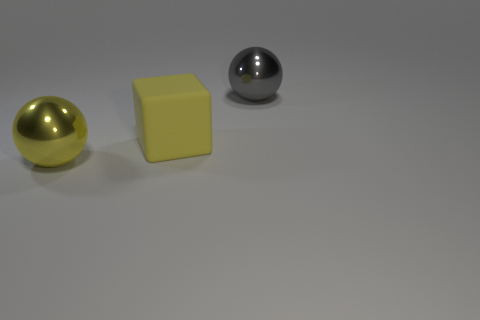Is the color of the large rubber thing the same as the large metallic ball that is in front of the gray metal thing?
Your response must be concise. Yes. Are there any shiny spheres of the same color as the rubber block?
Provide a short and direct response. Yes. How many other shiny objects are the same shape as the yellow metal object?
Provide a short and direct response. 1. What number of big blue shiny things are there?
Provide a succinct answer. 0. What color is the big thing on the left side of the yellow object to the right of the shiny object on the left side of the large gray metal sphere?
Make the answer very short. Yellow. How many metal spheres are to the left of the yellow matte object and behind the yellow cube?
Give a very brief answer. 0. How many matte things are either large gray spheres or small purple cylinders?
Keep it short and to the point. 0. The ball that is in front of the big shiny object that is behind the yellow metallic object is made of what material?
Your response must be concise. Metal. There is a large metal object that is the same color as the block; what shape is it?
Your response must be concise. Sphere. What shape is the gray metallic thing that is the same size as the yellow sphere?
Offer a terse response. Sphere. 